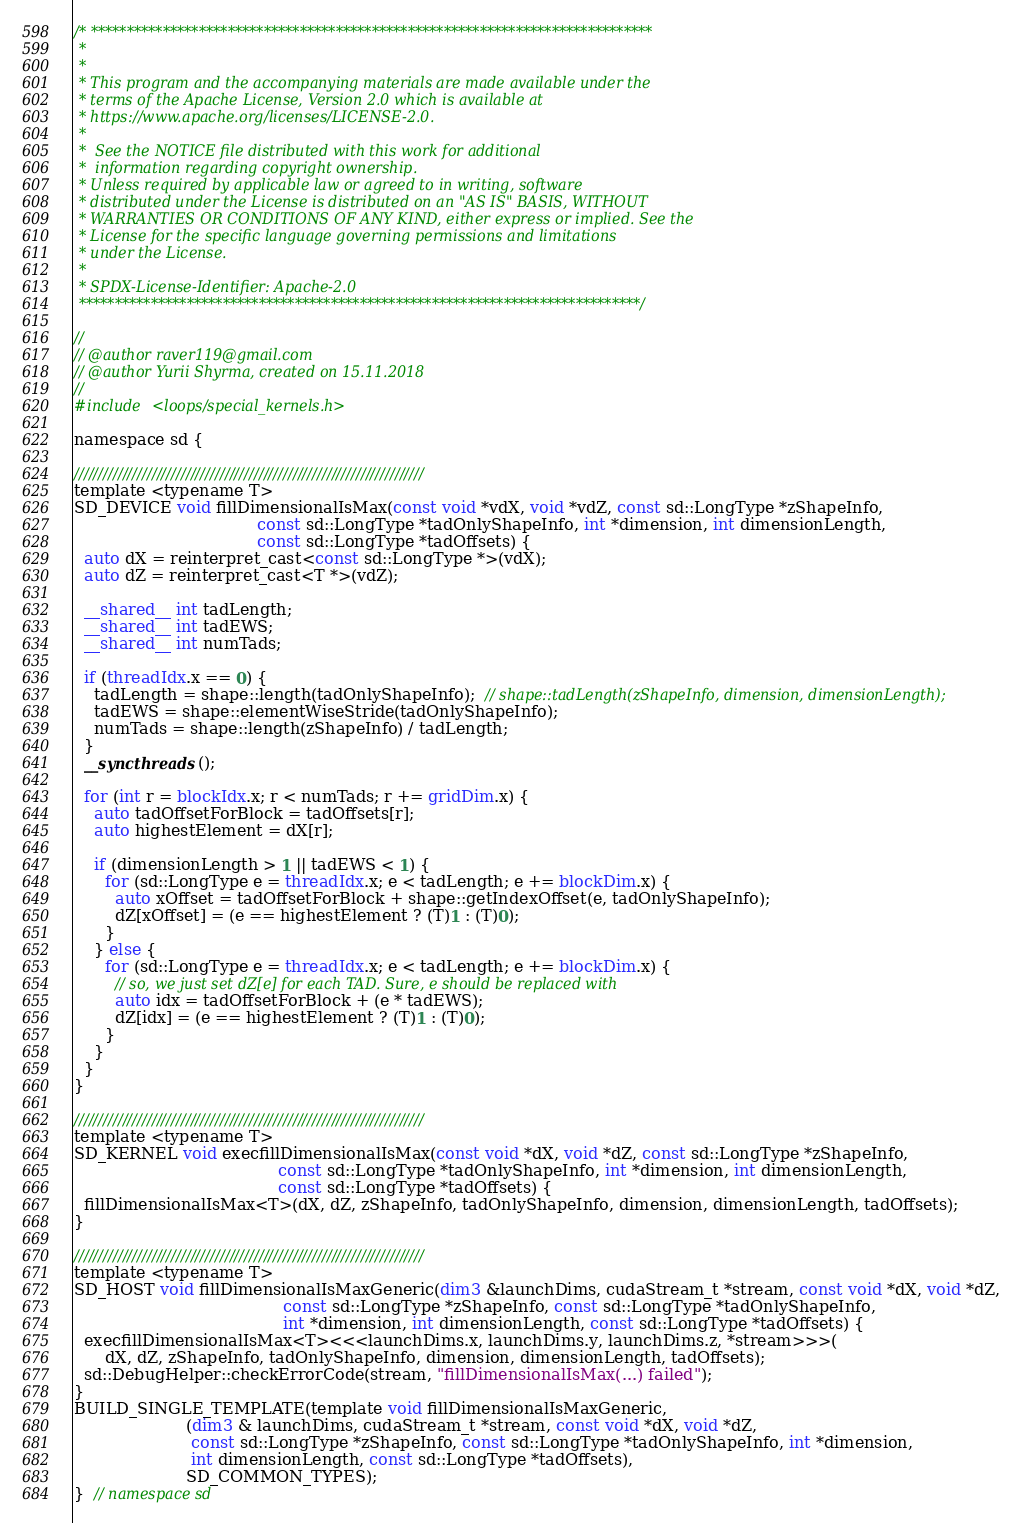<code> <loc_0><loc_0><loc_500><loc_500><_Cuda_>/* ******************************************************************************
 *
 *
 * This program and the accompanying materials are made available under the
 * terms of the Apache License, Version 2.0 which is available at
 * https://www.apache.org/licenses/LICENSE-2.0.
 *
 *  See the NOTICE file distributed with this work for additional
 *  information regarding copyright ownership.
 * Unless required by applicable law or agreed to in writing, software
 * distributed under the License is distributed on an "AS IS" BASIS, WITHOUT
 * WARRANTIES OR CONDITIONS OF ANY KIND, either express or implied. See the
 * License for the specific language governing permissions and limitations
 * under the License.
 *
 * SPDX-License-Identifier: Apache-2.0
 ******************************************************************************/

//
// @author raver119@gmail.com
// @author Yurii Shyrma, created on 15.11.2018
//
#include <loops/special_kernels.h>

namespace sd {

////////////////////////////////////////////////////////////////////////
template <typename T>
SD_DEVICE void fillDimensionalIsMax(const void *vdX, void *vdZ, const sd::LongType *zShapeInfo,
                                    const sd::LongType *tadOnlyShapeInfo, int *dimension, int dimensionLength,
                                    const sd::LongType *tadOffsets) {
  auto dX = reinterpret_cast<const sd::LongType *>(vdX);
  auto dZ = reinterpret_cast<T *>(vdZ);

  __shared__ int tadLength;
  __shared__ int tadEWS;
  __shared__ int numTads;

  if (threadIdx.x == 0) {
    tadLength = shape::length(tadOnlyShapeInfo);  // shape::tadLength(zShapeInfo, dimension, dimensionLength);
    tadEWS = shape::elementWiseStride(tadOnlyShapeInfo);
    numTads = shape::length(zShapeInfo) / tadLength;
  }
  __syncthreads();

  for (int r = blockIdx.x; r < numTads; r += gridDim.x) {
    auto tadOffsetForBlock = tadOffsets[r];
    auto highestElement = dX[r];

    if (dimensionLength > 1 || tadEWS < 1) {
      for (sd::LongType e = threadIdx.x; e < tadLength; e += blockDim.x) {
        auto xOffset = tadOffsetForBlock + shape::getIndexOffset(e, tadOnlyShapeInfo);
        dZ[xOffset] = (e == highestElement ? (T)1 : (T)0);
      }
    } else {
      for (sd::LongType e = threadIdx.x; e < tadLength; e += blockDim.x) {
        // so, we just set dZ[e] for each TAD. Sure, e should be replaced with
        auto idx = tadOffsetForBlock + (e * tadEWS);
        dZ[idx] = (e == highestElement ? (T)1 : (T)0);
      }
    }
  }
}

////////////////////////////////////////////////////////////////////////
template <typename T>
SD_KERNEL void execfillDimensionalIsMax(const void *dX, void *dZ, const sd::LongType *zShapeInfo,
                                        const sd::LongType *tadOnlyShapeInfo, int *dimension, int dimensionLength,
                                        const sd::LongType *tadOffsets) {
  fillDimensionalIsMax<T>(dX, dZ, zShapeInfo, tadOnlyShapeInfo, dimension, dimensionLength, tadOffsets);
}

////////////////////////////////////////////////////////////////////////
template <typename T>
SD_HOST void fillDimensionalIsMaxGeneric(dim3 &launchDims, cudaStream_t *stream, const void *dX, void *dZ,
                                         const sd::LongType *zShapeInfo, const sd::LongType *tadOnlyShapeInfo,
                                         int *dimension, int dimensionLength, const sd::LongType *tadOffsets) {
  execfillDimensionalIsMax<T><<<launchDims.x, launchDims.y, launchDims.z, *stream>>>(
      dX, dZ, zShapeInfo, tadOnlyShapeInfo, dimension, dimensionLength, tadOffsets);
  sd::DebugHelper::checkErrorCode(stream, "fillDimensionalIsMax(...) failed");
}
BUILD_SINGLE_TEMPLATE(template void fillDimensionalIsMaxGeneric,
                      (dim3 & launchDims, cudaStream_t *stream, const void *dX, void *dZ,
                       const sd::LongType *zShapeInfo, const sd::LongType *tadOnlyShapeInfo, int *dimension,
                       int dimensionLength, const sd::LongType *tadOffsets),
                      SD_COMMON_TYPES);
}  // namespace sd
</code> 